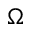<formula> <loc_0><loc_0><loc_500><loc_500>\Omega</formula> 